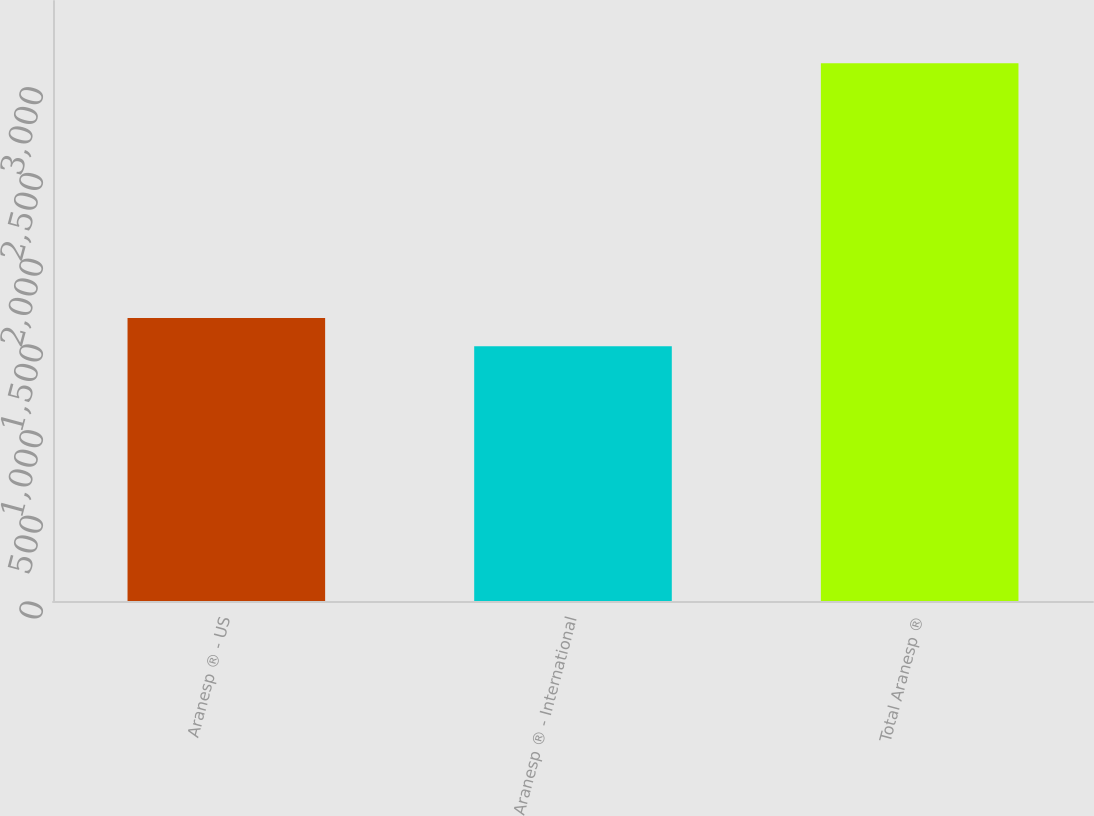Convert chart to OTSL. <chart><loc_0><loc_0><loc_500><loc_500><bar_chart><fcel>Aranesp ® - US<fcel>Aranesp ® - International<fcel>Total Aranesp ®<nl><fcel>1651.1<fcel>1486<fcel>3137<nl></chart> 